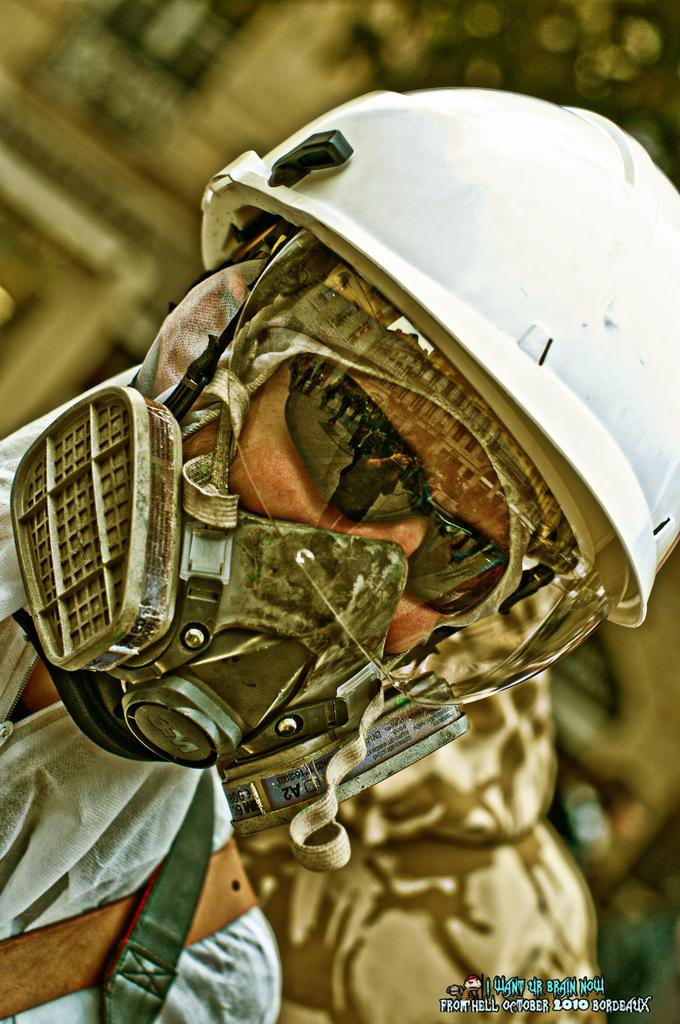What can be seen in the image? There is a person in the image. What protective gear is the person wearing? The person is wearing a mask, goggles, and a helmet. What is the condition of the background in the image? The background of the image is blurry. Is there any text visible in the image? Yes, there is some text in the right bottom corner of the image. How many lizards are crawling on the box in the image? There is no box or lizards present in the image. 